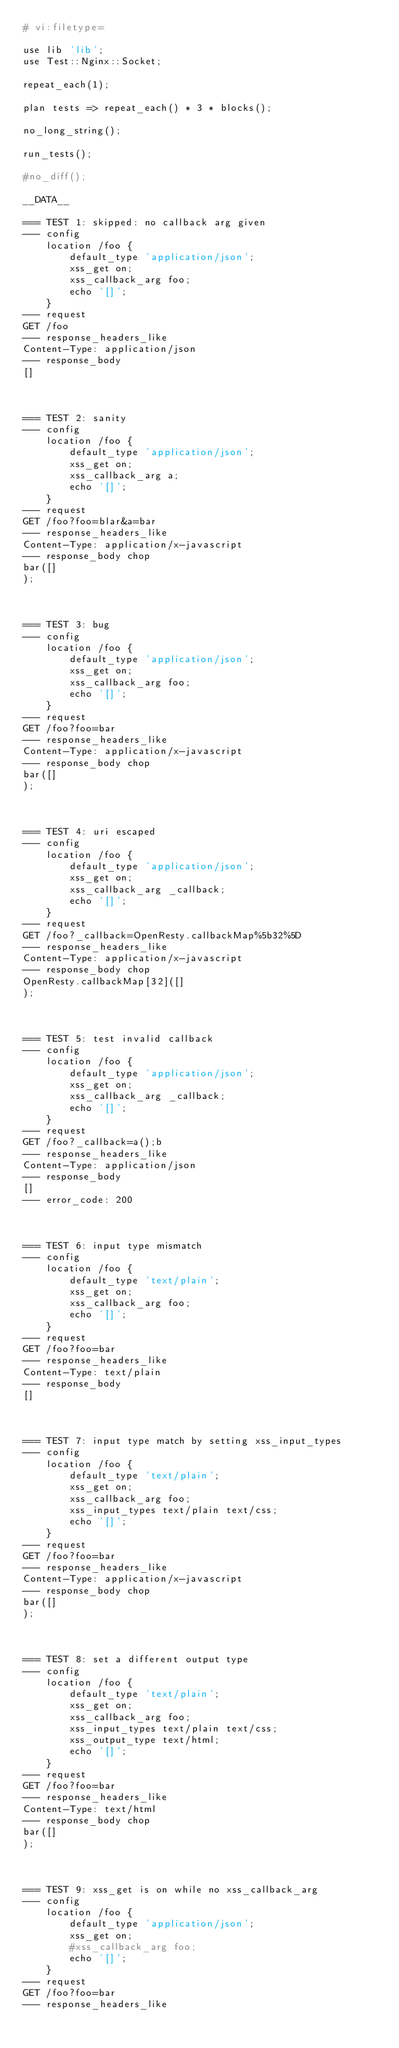<code> <loc_0><loc_0><loc_500><loc_500><_Perl_># vi:filetype=

use lib 'lib';
use Test::Nginx::Socket;

repeat_each(1);

plan tests => repeat_each() * 3 * blocks();

no_long_string();

run_tests();

#no_diff();

__DATA__

=== TEST 1: skipped: no callback arg given
--- config
    location /foo {
        default_type 'application/json';
        xss_get on;
        xss_callback_arg foo;
        echo '[]';
    }
--- request
GET /foo
--- response_headers_like
Content-Type: application/json
--- response_body
[]



=== TEST 2: sanity
--- config
    location /foo {
        default_type 'application/json';
        xss_get on;
        xss_callback_arg a;
        echo '[]';
    }
--- request
GET /foo?foo=blar&a=bar
--- response_headers_like
Content-Type: application/x-javascript
--- response_body chop
bar([]
);



=== TEST 3: bug
--- config
    location /foo {
        default_type 'application/json';
        xss_get on;
        xss_callback_arg foo;
        echo '[]';
    }
--- request
GET /foo?foo=bar
--- response_headers_like
Content-Type: application/x-javascript
--- response_body chop
bar([]
);



=== TEST 4: uri escaped
--- config
    location /foo {
        default_type 'application/json';
        xss_get on;
        xss_callback_arg _callback;
        echo '[]';
    }
--- request
GET /foo?_callback=OpenResty.callbackMap%5b32%5D
--- response_headers_like
Content-Type: application/x-javascript
--- response_body chop
OpenResty.callbackMap[32]([]
);



=== TEST 5: test invalid callback
--- config
    location /foo {
        default_type 'application/json';
        xss_get on;
        xss_callback_arg _callback;
        echo '[]';
    }
--- request
GET /foo?_callback=a();b
--- response_headers_like
Content-Type: application/json
--- response_body
[]
--- error_code: 200



=== TEST 6: input type mismatch
--- config
    location /foo {
        default_type 'text/plain';
        xss_get on;
        xss_callback_arg foo;
        echo '[]';
    }
--- request
GET /foo?foo=bar
--- response_headers_like
Content-Type: text/plain
--- response_body
[]



=== TEST 7: input type match by setting xss_input_types
--- config
    location /foo {
        default_type 'text/plain';
        xss_get on;
        xss_callback_arg foo;
        xss_input_types text/plain text/css;
        echo '[]';
    }
--- request
GET /foo?foo=bar
--- response_headers_like
Content-Type: application/x-javascript
--- response_body chop
bar([]
);



=== TEST 8: set a different output type
--- config
    location /foo {
        default_type 'text/plain';
        xss_get on;
        xss_callback_arg foo;
        xss_input_types text/plain text/css;
        xss_output_type text/html;
        echo '[]';
    }
--- request
GET /foo?foo=bar
--- response_headers_like
Content-Type: text/html
--- response_body chop
bar([]
);



=== TEST 9: xss_get is on while no xss_callback_arg
--- config
    location /foo {
        default_type 'application/json';
        xss_get on;
        #xss_callback_arg foo;
        echo '[]';
    }
--- request
GET /foo?foo=bar
--- response_headers_like</code> 